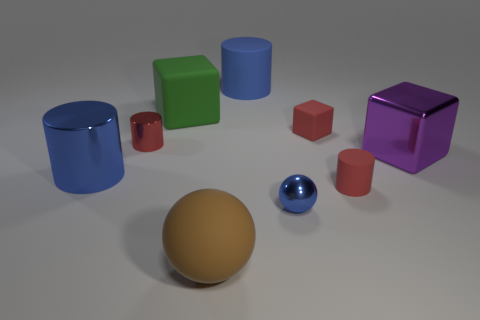Subtract all green matte blocks. How many blocks are left? 2 Subtract all yellow balls. How many red cylinders are left? 2 Subtract 1 blocks. How many blocks are left? 2 Subtract all cylinders. How many objects are left? 5 Subtract all red cylinders. How many cylinders are left? 2 Subtract all big yellow matte balls. Subtract all big metal cylinders. How many objects are left? 8 Add 2 red cubes. How many red cubes are left? 3 Add 5 big brown metallic blocks. How many big brown metallic blocks exist? 5 Subtract 0 cyan blocks. How many objects are left? 9 Subtract all purple blocks. Subtract all gray cylinders. How many blocks are left? 2 